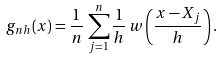<formula> <loc_0><loc_0><loc_500><loc_500>g _ { n h } ( x ) = \frac { 1 } { n } \, \sum _ { j = 1 } ^ { n } \frac { 1 } { h } \, w \left ( \frac { x - X _ { j } } { h } \right ) .</formula> 